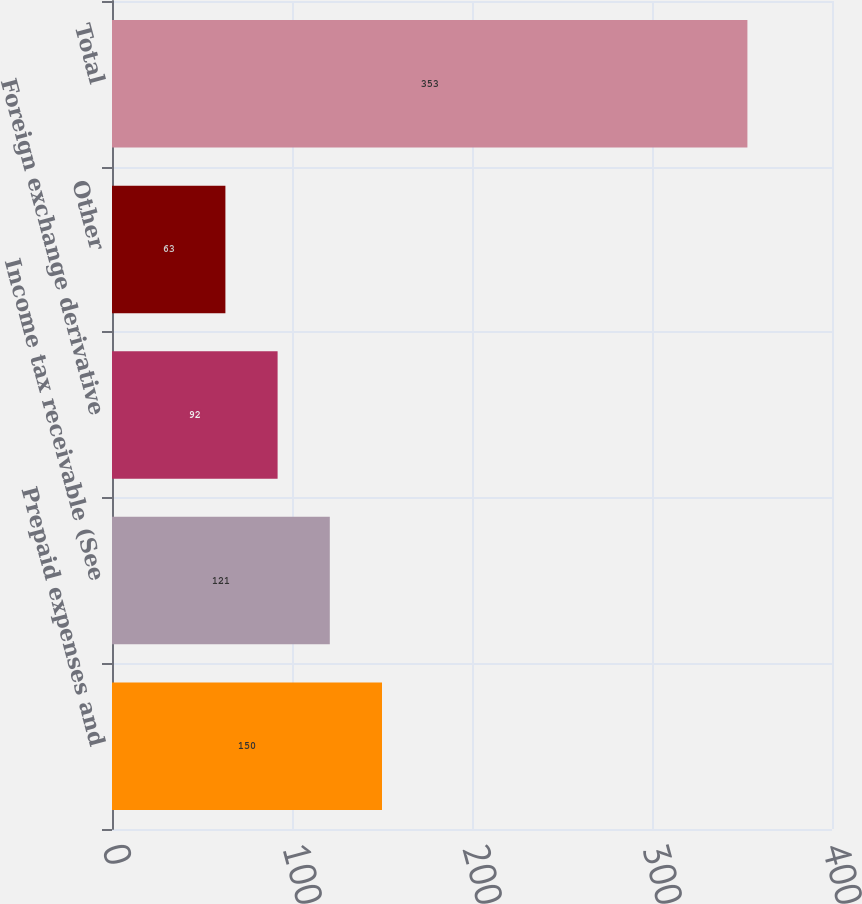Convert chart. <chart><loc_0><loc_0><loc_500><loc_500><bar_chart><fcel>Prepaid expenses and<fcel>Income tax receivable (See<fcel>Foreign exchange derivative<fcel>Other<fcel>Total<nl><fcel>150<fcel>121<fcel>92<fcel>63<fcel>353<nl></chart> 